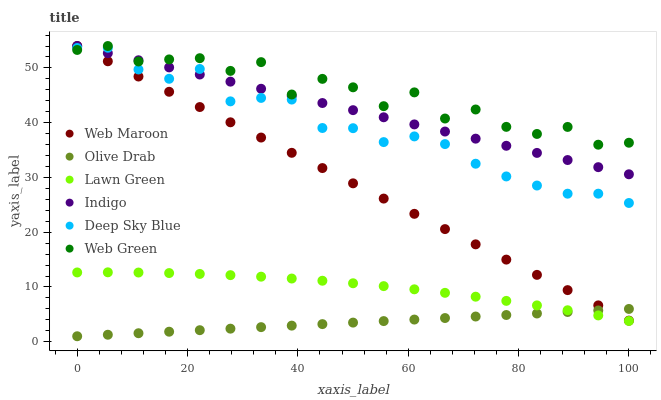Does Olive Drab have the minimum area under the curve?
Answer yes or no. Yes. Does Web Green have the maximum area under the curve?
Answer yes or no. Yes. Does Indigo have the minimum area under the curve?
Answer yes or no. No. Does Indigo have the maximum area under the curve?
Answer yes or no. No. Is Olive Drab the smoothest?
Answer yes or no. Yes. Is Web Green the roughest?
Answer yes or no. Yes. Is Indigo the smoothest?
Answer yes or no. No. Is Indigo the roughest?
Answer yes or no. No. Does Olive Drab have the lowest value?
Answer yes or no. Yes. Does Indigo have the lowest value?
Answer yes or no. No. Does Web Green have the highest value?
Answer yes or no. Yes. Does Deep Sky Blue have the highest value?
Answer yes or no. No. Is Olive Drab less than Web Green?
Answer yes or no. Yes. Is Web Green greater than Lawn Green?
Answer yes or no. Yes. Does Web Green intersect Deep Sky Blue?
Answer yes or no. Yes. Is Web Green less than Deep Sky Blue?
Answer yes or no. No. Is Web Green greater than Deep Sky Blue?
Answer yes or no. No. Does Olive Drab intersect Web Green?
Answer yes or no. No. 